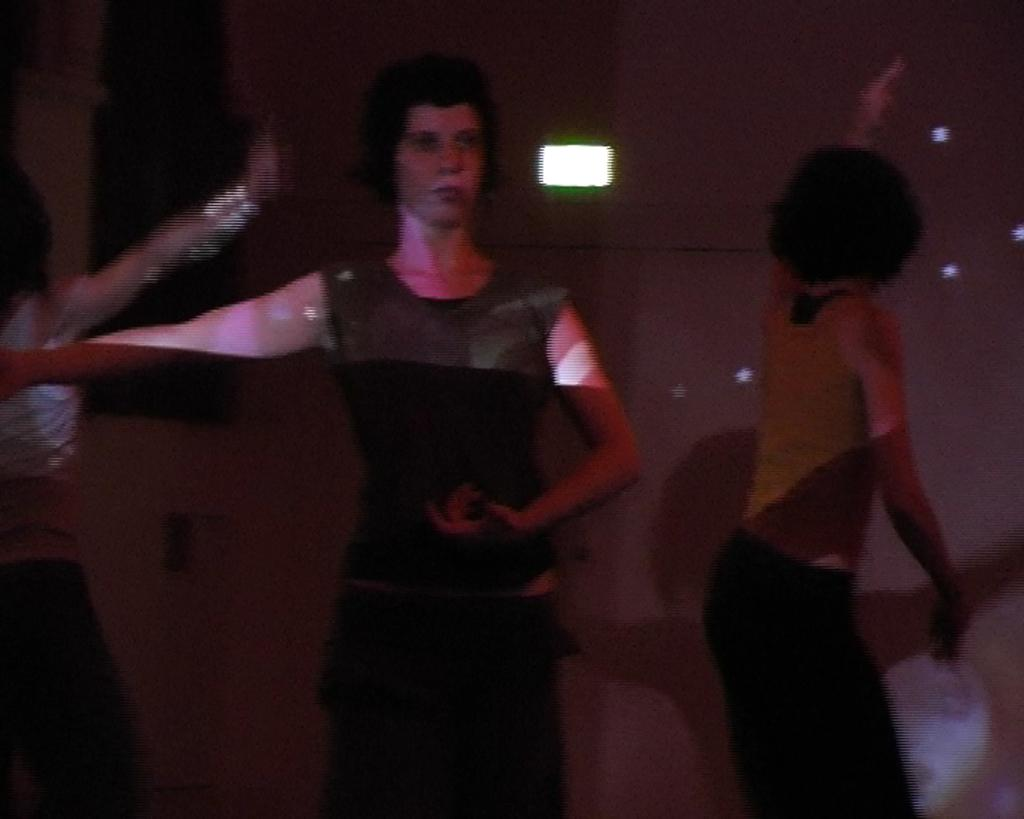How many people are present in the image? There are three people in the image. What are the people doing in the image? The people are dancing. Can you describe the background of the image? There are lights on the wall in the background of the image. What type of joke is being told by the person on the left in the image? There is no indication in the image that a joke is being told, and therefore it cannot be determined who might be telling a joke or what type of joke it might be. 